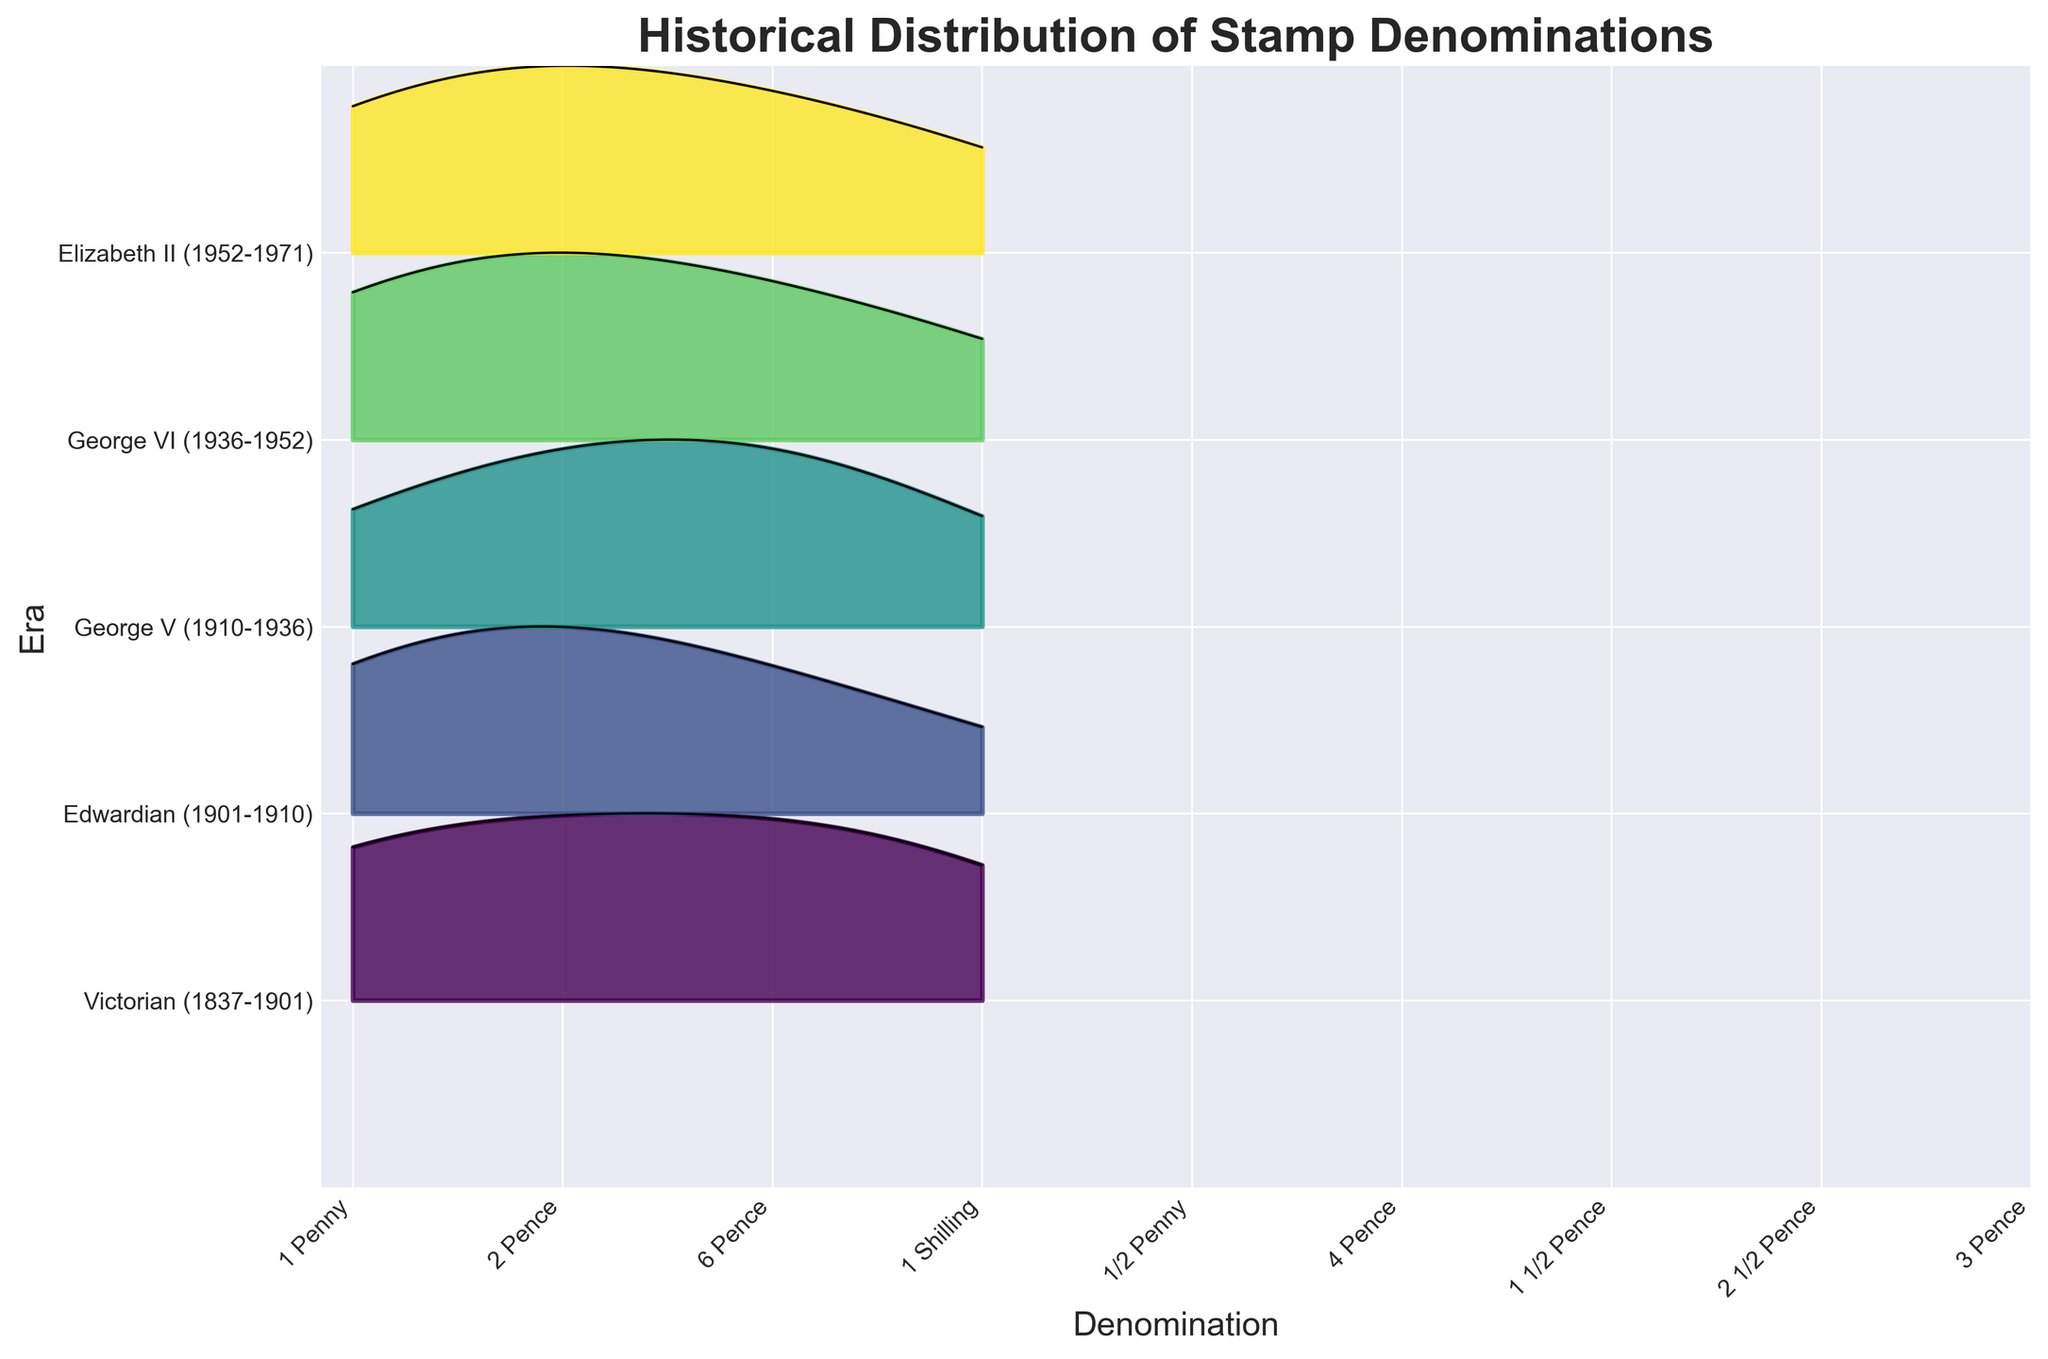How many eras are represented in the plot? The plot shows several colored ridgeline curves, each labeled with a distinct era on the y-axis. Count these to determine the number of eras.
Answer: 5 What is the title of the figure? The title is typically found at the top of the figure in larger, bold text.
Answer: Historical Distribution of Stamp Denominations Which denomination appears most frequently in the Elizabeth II era? Look at the ridgeline for the Elizabeth II era (labeled on the y-axis) and identify the peak, then match it to the corresponding denomination on the x-axis.
Answer: 1/2 Penny Which era has the highest frequency of 1/2 Penny stamps? Find the denomination 1/2 Penny on the x-axis, and then look at the peaks of the ridgeline that intersect it. Identify which era's curve has the highest peak at this denomination.
Answer: Elizabeth II (1952-1971) Compare the frequency of 1 Penny stamps between the Victorian and George VI era. Which era has more? Locate the denomination 1 Penny on the x-axis and observe the height of its peaks in both the Victorian and George VI ridgelines. The era with the higher peak indicates more frequency.
Answer: George VI (1936-1952) What is the least common denomination in the Edwardian era? Identify the ridgeline for the Edwardian era and observe the heights of the peaks for each denomination on the x-axis. The smallest peak represents the least common denomination.
Answer: 4 Pence Which era shows the most variability in stamp denominations? Evaluate the ridgelines for each era; the one with the widest spread or most diverse set of peaks (both height and x-axis coverage) shows the most variability.
Answer: Elizabeth II (1952-1971) Identify which eras have denominations that appear uniquely in their respective time periods (not shared with other eras). Determine the denominations for each era on the x-axis, then check which denominations correspond to a single era only.
Answer: 6 Pence in Victorian, 4 Pence in Edwardian, 1 1/2 Pence and 2 1/2 Pence in George V, 3 Pence in George VI, 6 Pence in Elizabeth II How does the frequency distribution of 2 Pence stamps change over different eras? Trace the height of the peaks for the denomination 2 Pence across all ridgelines, noting any increases or decreases in peak height across different eras.
Answer: Peaks: 25 (Victorian), 20 (Edwardian), negligible (George V), 30 (George VI), negligible (Elizabeth II) What is the average frequency of 1 Penny stamps across all eras? Locate the 1 Penny denomination on the x-axis and note the peak heights for each era: Victorian, Edwardian, George V, George VI, and Elizabeth II. Sum these values and divide by the number of eras.
Answer: \( (30 + 30 + 35 + 40 + 45) / 5 = 36 \) 